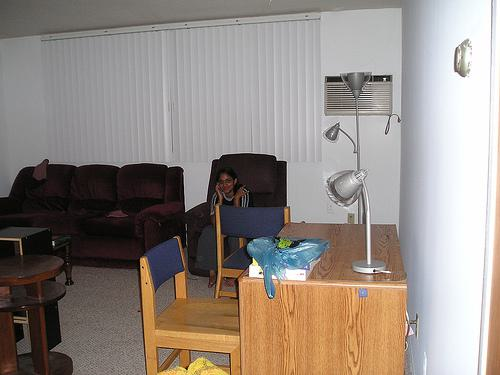Can you tell me what activities may take place in this room based on the arrangement and items present? The room's setup, with seating like a couch and chairs arranged to face each other, hints at socializing and relaxation, commonly associated with activities such as watching TV, reading, or engaging in conversations with guests. 